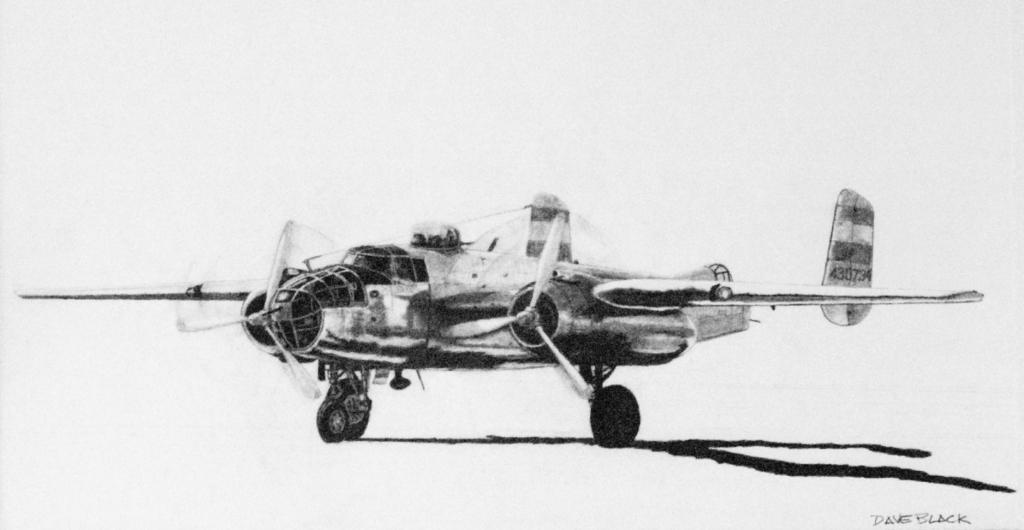How would you summarize this image in a sentence or two? In the picture I can see a plane and there is something written in the right bottom corner. 